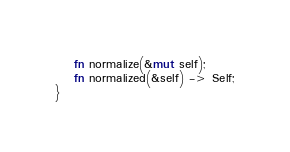<code> <loc_0><loc_0><loc_500><loc_500><_Rust_>    fn normalize(&mut self);
    fn normalized(&self) -> Self;
}</code> 